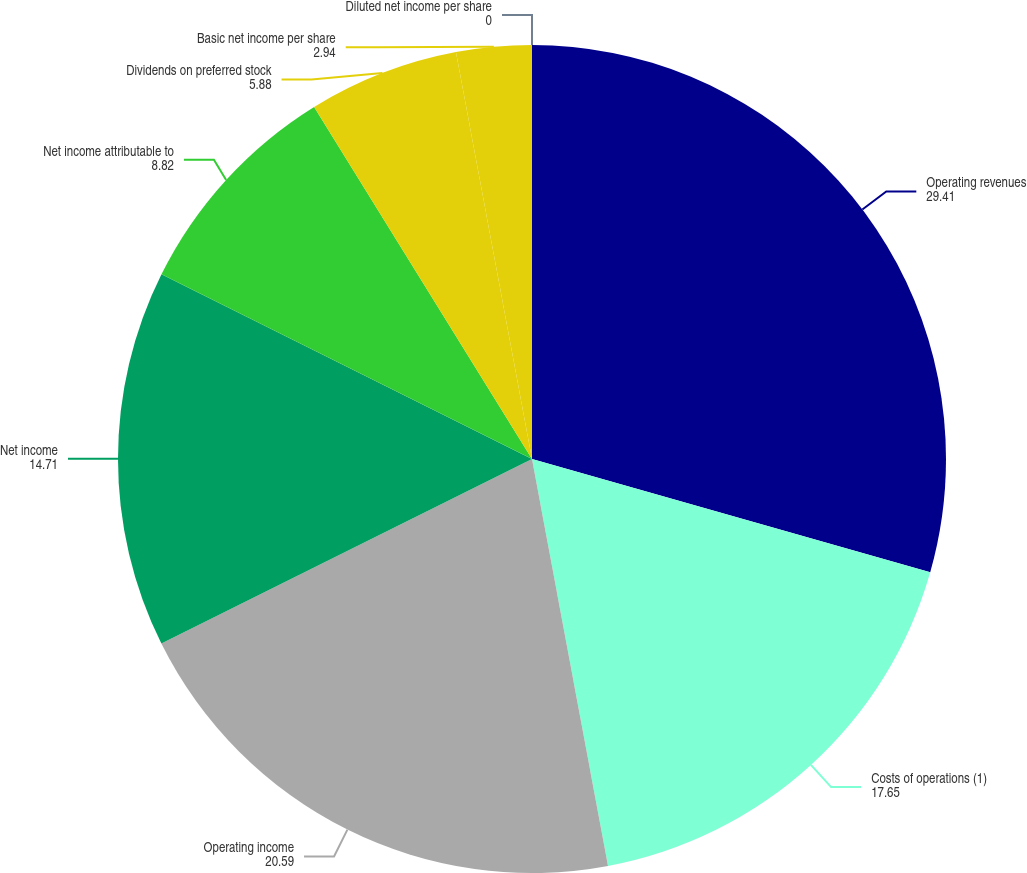Convert chart to OTSL. <chart><loc_0><loc_0><loc_500><loc_500><pie_chart><fcel>Operating revenues<fcel>Costs of operations (1)<fcel>Operating income<fcel>Net income<fcel>Net income attributable to<fcel>Dividends on preferred stock<fcel>Basic net income per share<fcel>Diluted net income per share<nl><fcel>29.41%<fcel>17.65%<fcel>20.59%<fcel>14.71%<fcel>8.82%<fcel>5.88%<fcel>2.94%<fcel>0.0%<nl></chart> 